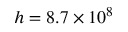Convert formula to latex. <formula><loc_0><loc_0><loc_500><loc_500>h = 8 . 7 \times 1 0 ^ { 8 }</formula> 